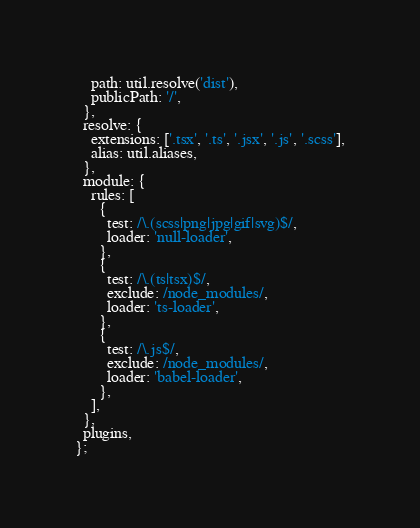Convert code to text. <code><loc_0><loc_0><loc_500><loc_500><_JavaScript_>    path: util.resolve('dist'),
    publicPath: '/',
  },
  resolve: {
    extensions: ['.tsx', '.ts', '.jsx', '.js', '.scss'],
    alias: util.aliases,
  },
  module: {
    rules: [
      {
        test: /\.(scss|png|jpg|gif|svg)$/,
        loader: 'null-loader',
      },
      {
        test: /\.(ts|tsx)$/,
        exclude: /node_modules/,
        loader: 'ts-loader',
      },
      {
        test: /\.js$/,
        exclude: /node_modules/,
        loader: 'babel-loader',
      },
    ],
  },
  plugins,
};
</code> 